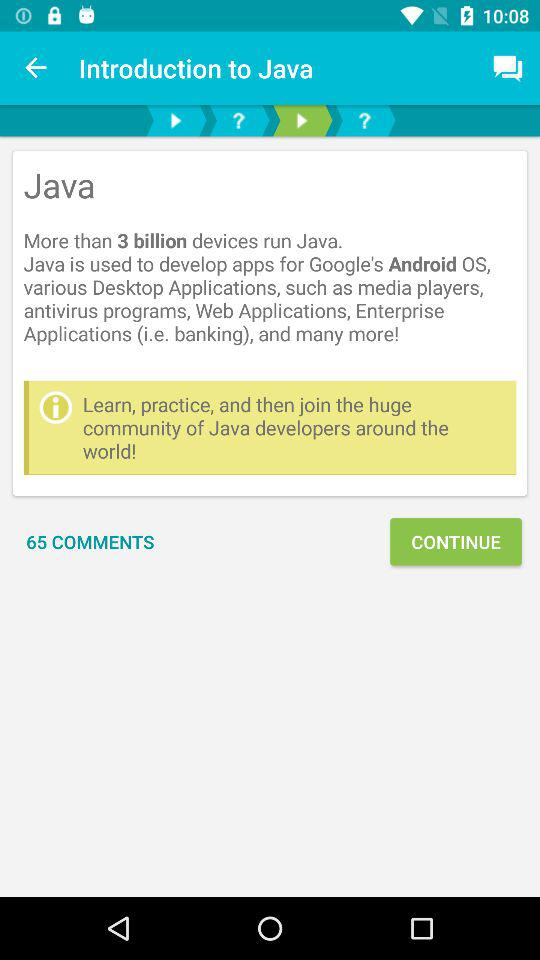What is the name of the application? The name of the application is "Learn Java". 